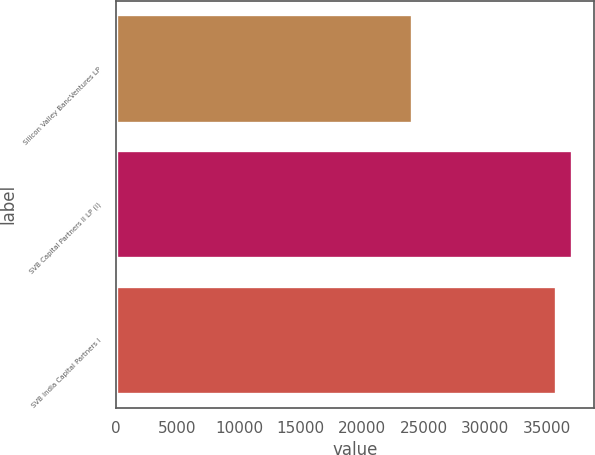Convert chart. <chart><loc_0><loc_0><loc_500><loc_500><bar_chart><fcel>Silicon Valley BancVentures LP<fcel>SVB Capital Partners II LP (i)<fcel>SVB India Capital Partners I<nl><fcel>24023<fcel>36989.4<fcel>35707<nl></chart> 